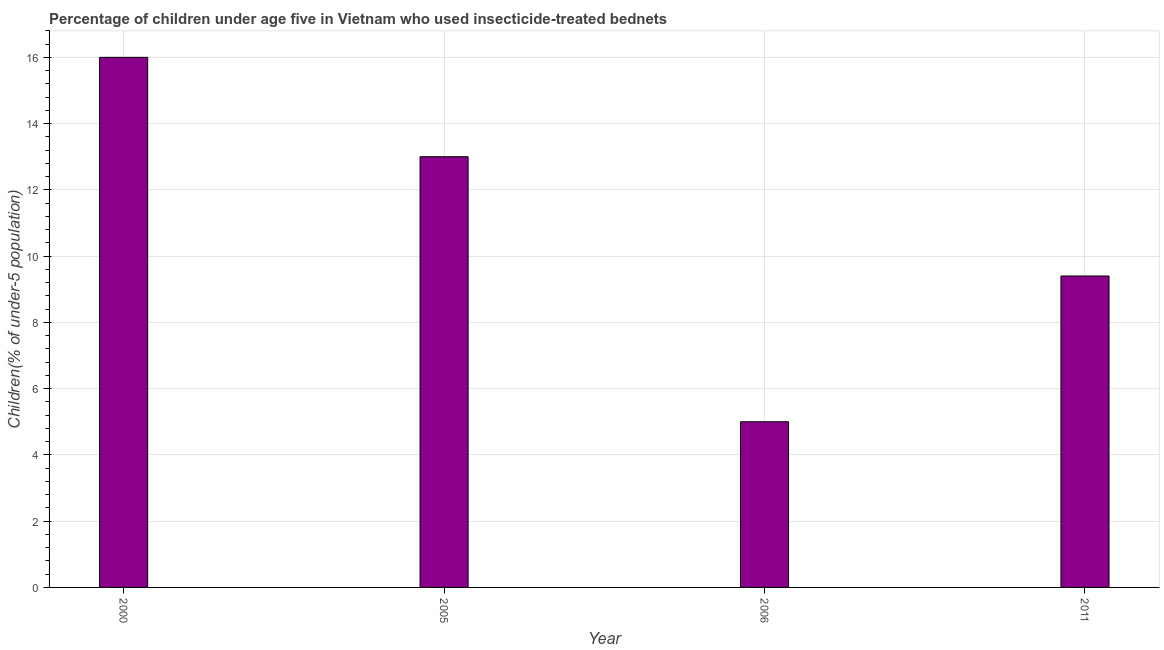Does the graph contain grids?
Your response must be concise. Yes. What is the title of the graph?
Ensure brevity in your answer.  Percentage of children under age five in Vietnam who used insecticide-treated bednets. What is the label or title of the X-axis?
Your answer should be compact. Year. What is the label or title of the Y-axis?
Your answer should be compact. Children(% of under-5 population). Across all years, what is the maximum percentage of children who use of insecticide-treated bed nets?
Ensure brevity in your answer.  16. Across all years, what is the minimum percentage of children who use of insecticide-treated bed nets?
Provide a short and direct response. 5. What is the sum of the percentage of children who use of insecticide-treated bed nets?
Your answer should be very brief. 43.4. What is the average percentage of children who use of insecticide-treated bed nets per year?
Your answer should be compact. 10.85. What is the median percentage of children who use of insecticide-treated bed nets?
Keep it short and to the point. 11.2. Is the difference between the percentage of children who use of insecticide-treated bed nets in 2000 and 2006 greater than the difference between any two years?
Your response must be concise. Yes. What is the difference between the highest and the second highest percentage of children who use of insecticide-treated bed nets?
Offer a very short reply. 3. Is the sum of the percentage of children who use of insecticide-treated bed nets in 2005 and 2011 greater than the maximum percentage of children who use of insecticide-treated bed nets across all years?
Give a very brief answer. Yes. How many bars are there?
Make the answer very short. 4. What is the difference between the Children(% of under-5 population) in 2000 and 2011?
Your answer should be very brief. 6.6. What is the ratio of the Children(% of under-5 population) in 2000 to that in 2005?
Your answer should be compact. 1.23. What is the ratio of the Children(% of under-5 population) in 2000 to that in 2006?
Offer a terse response. 3.2. What is the ratio of the Children(% of under-5 population) in 2000 to that in 2011?
Make the answer very short. 1.7. What is the ratio of the Children(% of under-5 population) in 2005 to that in 2011?
Your response must be concise. 1.38. What is the ratio of the Children(% of under-5 population) in 2006 to that in 2011?
Your response must be concise. 0.53. 